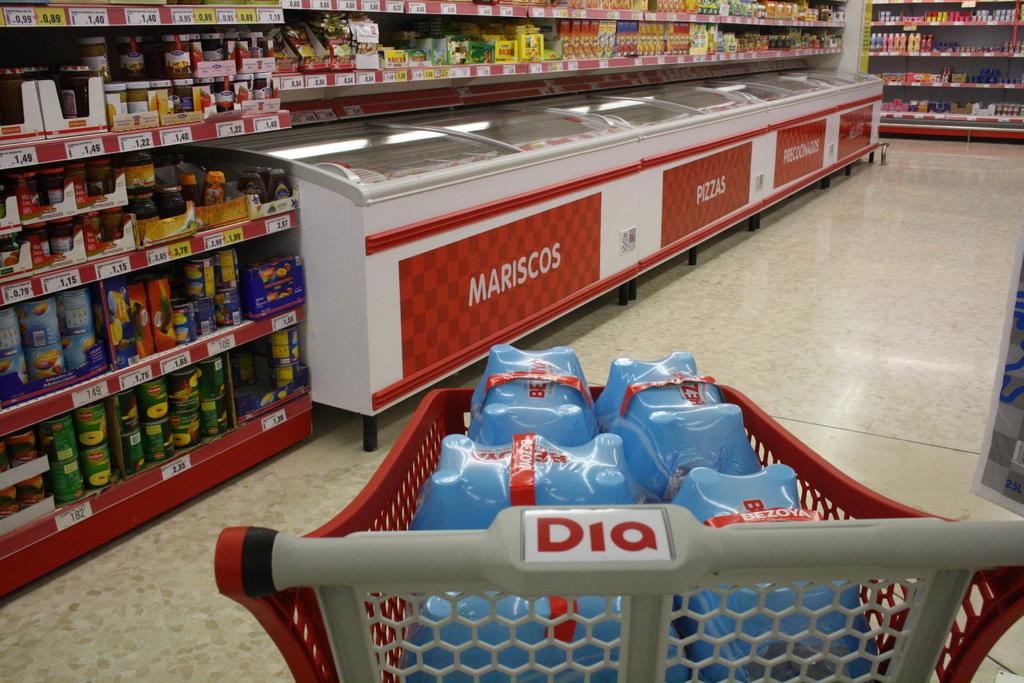What is the name on the cart handle?
Give a very brief answer. Dia. This is big computer television?
Your answer should be very brief. No. 